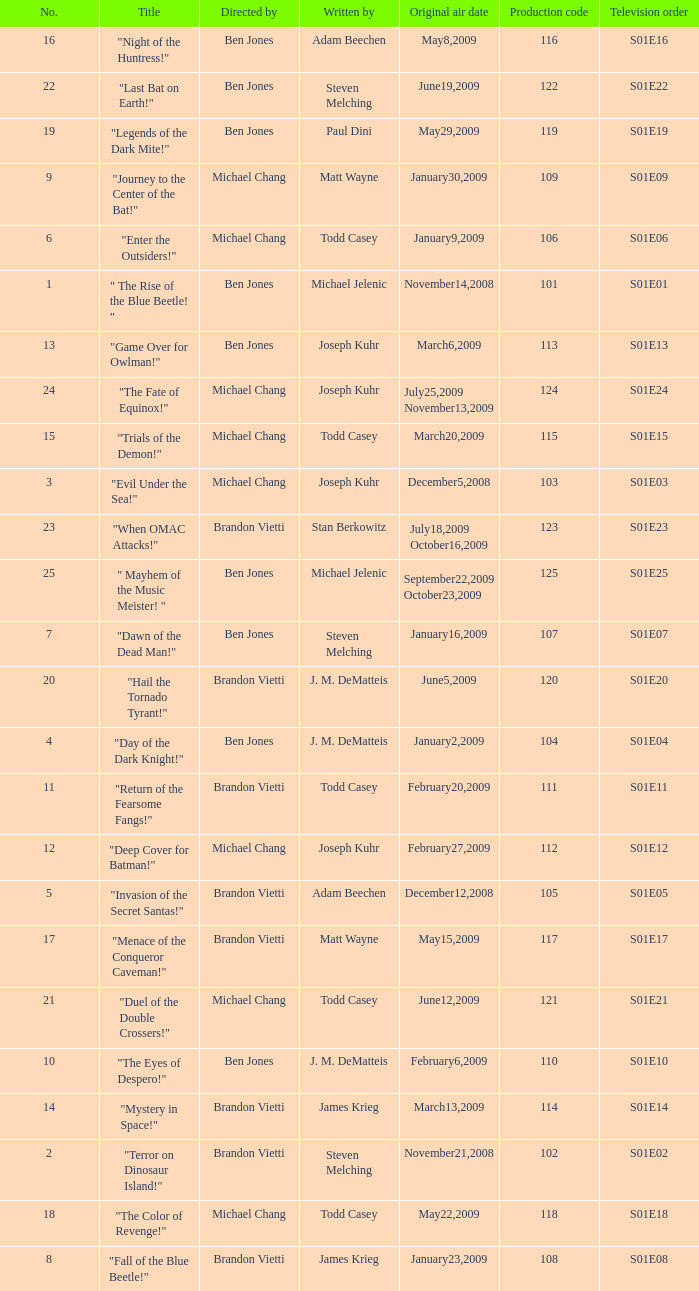Who wrote s01e06 Todd Casey. 